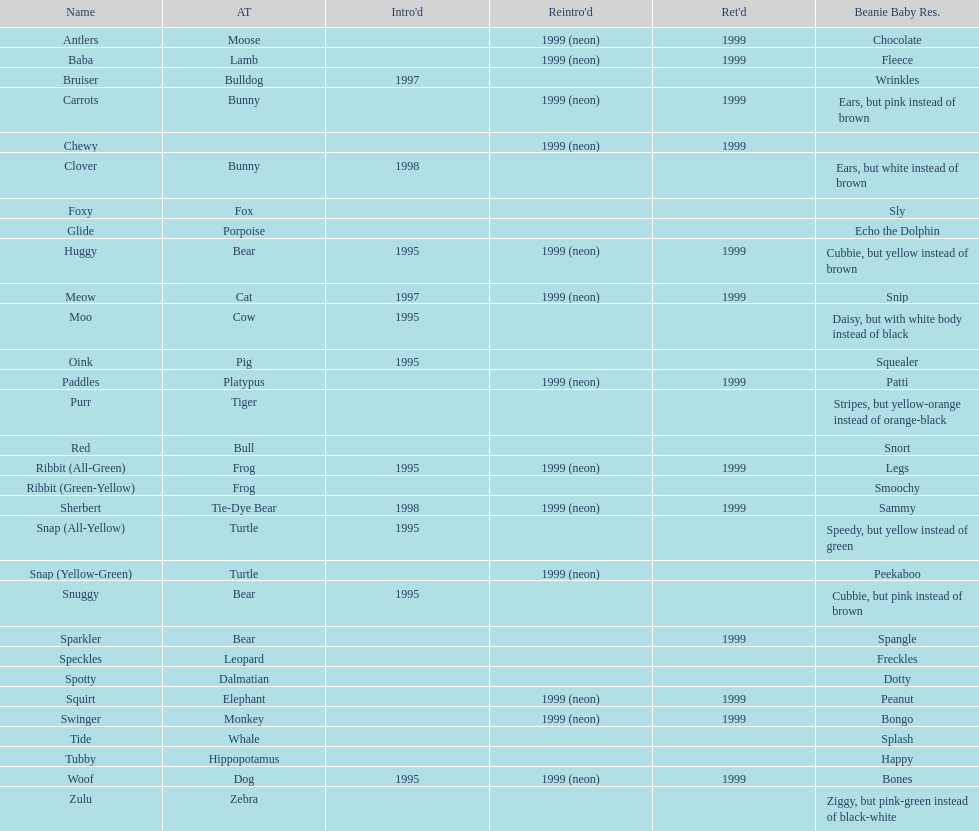Which animal group has the highest number of pillow pals? Bear. 